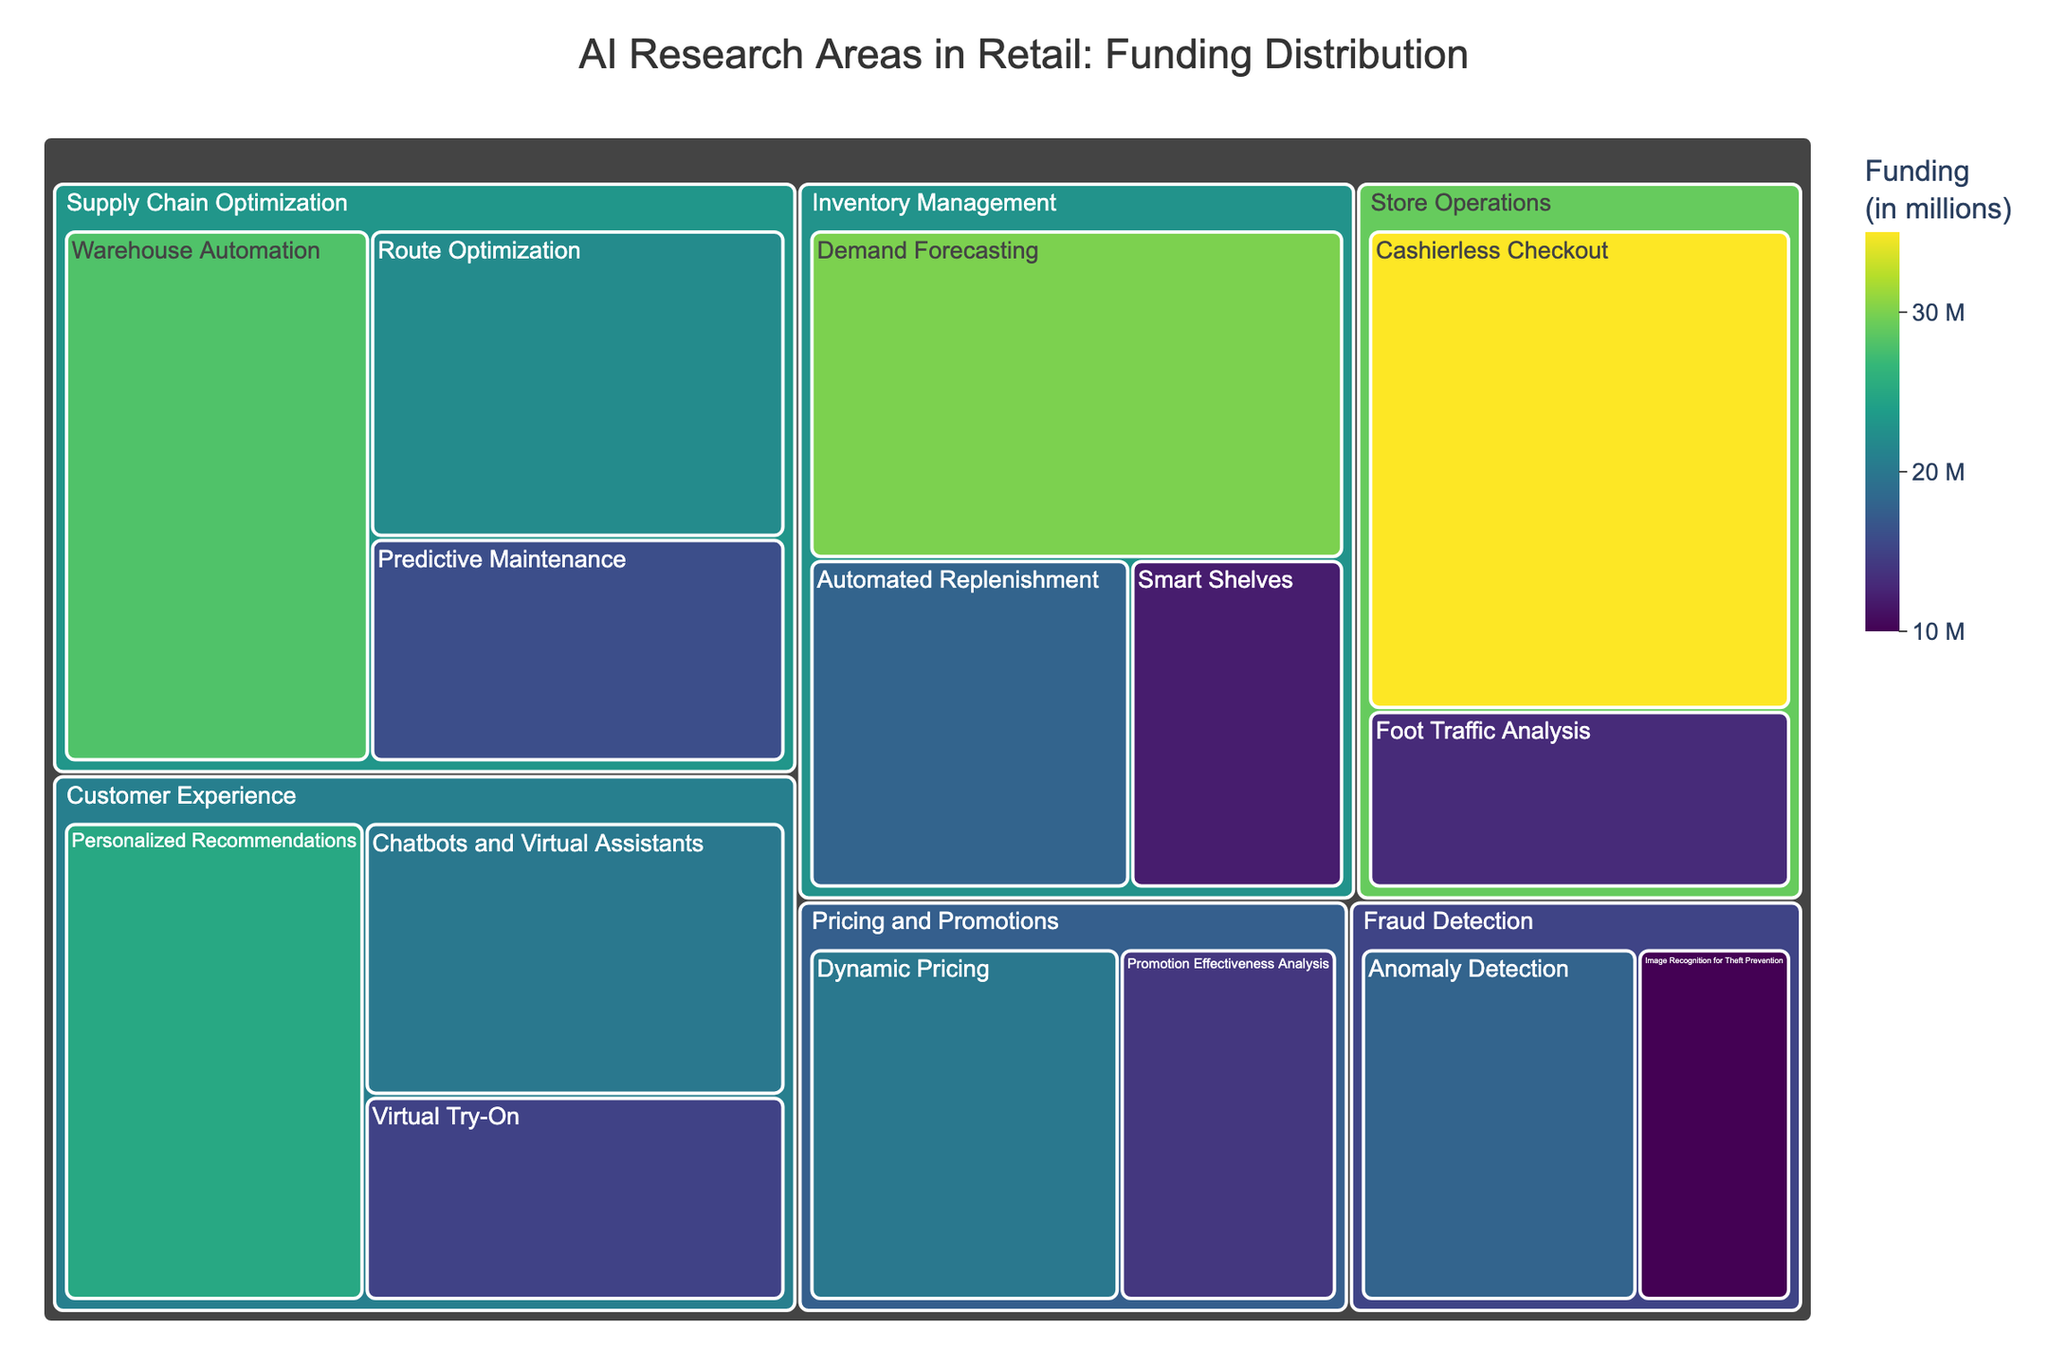What is the title of the treemap? The title is usually displayed prominently at the top of the figure and is clear and descriptive.
Answer: AI Research Areas in Retail: Funding Distribution Which application domain has received the highest total funding? To find this, sum up the funding for each research area within an application domain and compare the totals. Adding up all the values for each domain: Customer Experience ($25M + $15M + $20M = $60M), Inventory Management ($30M + $18M + $12M = $60M), Supply Chain Optimization ($22M + $16M + $28M = $66M), Pricing and Promotions ($20M + $14M = $34M), Fraud Detection ($18M + $10M = $28M), Store Operations ($35M + $13M = $48M). Supply Chain Optimization has the highest total funding of $66M.
Answer: Supply Chain Optimization How much more funding has 'Cashierless Checkout' received compared to 'Foot Traffic Analysis'? Locate the funding amounts for both research areas and subtract the smaller number from the larger one. 'Cashierless Checkout' funding is $35M and 'Foot Traffic Analysis' is $13M. The difference is $35M - $13M = $22M.
Answer: $22M Which research area has the smallest funding? Look for the research area with the smallest value in the figure. 'Image Recognition for Theft Prevention' in Fraud Detection has the smallest funding which is $10M.
Answer: Image Recognition for Theft Prevention What is the total funding for Inventory Management? Sum the funding amounts for all research areas under Inventory Management. These are: Demand Forecasting ($30M), Automated Replenishment ($18M), and Smart Shelves ($12M). Total is $30M + $18M + $12M = $60M.
Answer: $60M Compare the funding for 'Dynamic Pricing' and 'Promotion Effectiveness Analysis'. Which has higher funding and by how much? Identify the funding for each research area: Dynamic Pricing ($20M) and Promotion Effectiveness Analysis ($14M). Compare the two: $20M is higher than $14M by $6M.
Answer: Dynamic Pricing by $6M What is the average funding for research areas within Customer Experience? Sum the funding amounts for all research areas under Customer Experience and divide by the number of research areas. Total funding is $25M + $15M + $20M = $60M. There are 3 research areas, so the average is $60M / 3 = $20M.
Answer: $20M Which research areas under Supply Chain Optimization have funding above $20M? Identify and compare the funding amounts for each research area within Supply Chain Optimization: Route Optimization ($22M), Predictive Maintenance ($16M), and Warehouse Automation ($28M). Both Route Optimization and Warehouse Automation have funding above $20M.
Answer: Route Optimization and Warehouse Automation How does the funding for 'Personalized Recommendations' compare to 'Demand Forecasting'? Locate the funding numbers of each research area: Personalized Recommendations ($25M) and Demand Forecasting ($30M). Demand Forecasting ($30M) has higher funding than Personalized Recommendations ($25M).
Answer: Demand Forecasting has higher funding In which application domain does 'Virtual Try-On' belong, and what is its funding? Look for 'Virtual Try-On' in the figure. It is under the Customer Experience application domain with a funding of $15M.
Answer: Customer Experience, $15M 